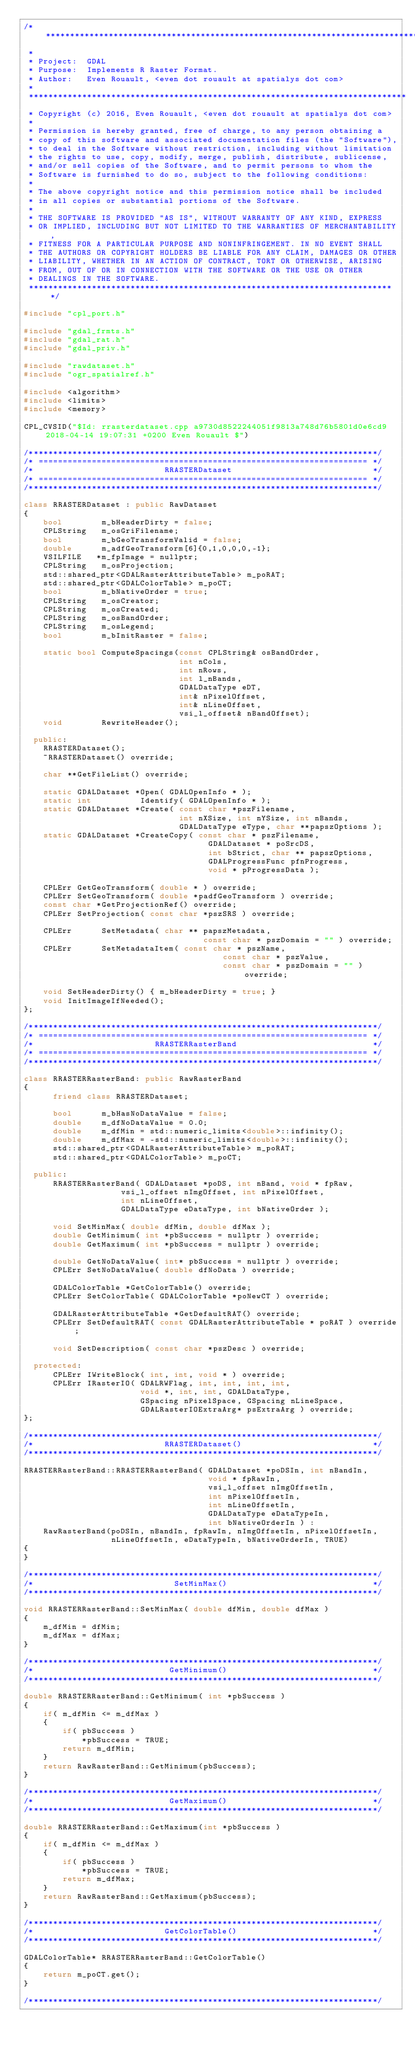Convert code to text. <code><loc_0><loc_0><loc_500><loc_500><_C++_>/******************************************************************************
 *
 * Project:  GDAL
 * Purpose:  Implements R Raster Format.
 * Author:   Even Rouault, <even dot rouault at spatialys dot com>
 *
 ******************************************************************************
 * Copyright (c) 2016, Even Rouault, <even dot rouault at spatialys dot com>
 *
 * Permission is hereby granted, free of charge, to any person obtaining a
 * copy of this software and associated documentation files (the "Software"),
 * to deal in the Software without restriction, including without limitation
 * the rights to use, copy, modify, merge, publish, distribute, sublicense,
 * and/or sell copies of the Software, and to permit persons to whom the
 * Software is furnished to do so, subject to the following conditions:
 *
 * The above copyright notice and this permission notice shall be included
 * in all copies or substantial portions of the Software.
 *
 * THE SOFTWARE IS PROVIDED "AS IS", WITHOUT WARRANTY OF ANY KIND, EXPRESS
 * OR IMPLIED, INCLUDING BUT NOT LIMITED TO THE WARRANTIES OF MERCHANTABILITY,
 * FITNESS FOR A PARTICULAR PURPOSE AND NONINFRINGEMENT. IN NO EVENT SHALL
 * THE AUTHORS OR COPYRIGHT HOLDERS BE LIABLE FOR ANY CLAIM, DAMAGES OR OTHER
 * LIABILITY, WHETHER IN AN ACTION OF CONTRACT, TORT OR OTHERWISE, ARISING
 * FROM, OUT OF OR IN CONNECTION WITH THE SOFTWARE OR THE USE OR OTHER
 * DEALINGS IN THE SOFTWARE.
 ****************************************************************************/

#include "cpl_port.h"

#include "gdal_frmts.h"
#include "gdal_rat.h"
#include "gdal_priv.h"

#include "rawdataset.h"
#include "ogr_spatialref.h"

#include <algorithm>
#include <limits>
#include <memory>

CPL_CVSID("$Id: rrasterdataset.cpp a9730d8522244051f9813a748d76b5801d0e6cd9 2018-04-14 19:07:31 +0200 Even Rouault $")

/************************************************************************/
/* ==================================================================== */
/*                           RRASTERDataset                             */
/* ==================================================================== */
/************************************************************************/

class RRASTERDataset : public RawDataset
{
    bool        m_bHeaderDirty = false;
    CPLString   m_osGriFilename;
    bool        m_bGeoTransformValid = false;
    double      m_adfGeoTransform[6]{0,1,0,0,0,-1};
    VSILFILE   *m_fpImage = nullptr;
    CPLString   m_osProjection;
    std::shared_ptr<GDALRasterAttributeTable> m_poRAT;
    std::shared_ptr<GDALColorTable> m_poCT;
    bool        m_bNativeOrder = true;
    CPLString   m_osCreator;
    CPLString   m_osCreated;
    CPLString   m_osBandOrder;
    CPLString   m_osLegend;
    bool        m_bInitRaster = false;

    static bool ComputeSpacings(const CPLString& osBandOrder,
                                int nCols,
                                int nRows,
                                int l_nBands,
                                GDALDataType eDT,
                                int& nPixelOffset,
                                int& nLineOffset,
                                vsi_l_offset& nBandOffset);
    void        RewriteHeader();

  public:
    RRASTERDataset();
    ~RRASTERDataset() override;

    char **GetFileList() override;

    static GDALDataset *Open( GDALOpenInfo * );
    static int          Identify( GDALOpenInfo * );
    static GDALDataset *Create( const char *pszFilename,
                                int nXSize, int nYSize, int nBands,
                                GDALDataType eType, char **papszOptions );
    static GDALDataset *CreateCopy( const char * pszFilename,
                                      GDALDataset * poSrcDS,
                                      int bStrict, char ** papszOptions,
                                      GDALProgressFunc pfnProgress,
                                      void * pProgressData );

    CPLErr GetGeoTransform( double * ) override;
    CPLErr SetGeoTransform( double *padfGeoTransform ) override;
    const char *GetProjectionRef() override;
    CPLErr SetProjection( const char *pszSRS ) override;

    CPLErr      SetMetadata( char ** papszMetadata,
                                     const char * pszDomain = "" ) override;
    CPLErr      SetMetadataItem( const char * pszName,
                                         const char * pszValue,
                                         const char * pszDomain = "" ) override;

    void SetHeaderDirty() { m_bHeaderDirty = true; }
    void InitImageIfNeeded();
};

/************************************************************************/
/* ==================================================================== */
/*                         RRASTERRasterBand                            */
/* ==================================================================== */
/************************************************************************/

class RRASTERRasterBand: public RawRasterBand
{
      friend class RRASTERDataset;

      bool      m_bHasNoDataValue = false;
      double    m_dfNoDataValue = 0.0;
      double    m_dfMin = std::numeric_limits<double>::infinity();
      double    m_dfMax = -std::numeric_limits<double>::infinity();
      std::shared_ptr<GDALRasterAttributeTable> m_poRAT;
      std::shared_ptr<GDALColorTable> m_poCT;

  public:
      RRASTERRasterBand( GDALDataset *poDS, int nBand, void * fpRaw,
                    vsi_l_offset nImgOffset, int nPixelOffset,
                    int nLineOffset,
                    GDALDataType eDataType, int bNativeOrder );

      void SetMinMax( double dfMin, double dfMax );
      double GetMinimum( int *pbSuccess = nullptr ) override;
      double GetMaximum( int *pbSuccess = nullptr ) override;

      double GetNoDataValue( int* pbSuccess = nullptr ) override;
      CPLErr SetNoDataValue( double dfNoData ) override;

      GDALColorTable *GetColorTable() override;
      CPLErr SetColorTable( GDALColorTable *poNewCT ) override;

      GDALRasterAttributeTable *GetDefaultRAT() override;
      CPLErr SetDefaultRAT( const GDALRasterAttributeTable * poRAT ) override;

      void SetDescription( const char *pszDesc ) override;

  protected:
      CPLErr IWriteBlock( int, int, void * ) override;
      CPLErr IRasterIO( GDALRWFlag, int, int, int, int,
                        void *, int, int, GDALDataType,
                        GSpacing nPixelSpace, GSpacing nLineSpace,
                        GDALRasterIOExtraArg* psExtraArg ) override;
};

/************************************************************************/
/*                           RRASTERDataset()                           */
/************************************************************************/

RRASTERRasterBand::RRASTERRasterBand( GDALDataset *poDSIn, int nBandIn,
                                      void * fpRawIn,
                                      vsi_l_offset nImgOffsetIn,
                                      int nPixelOffsetIn,
                                      int nLineOffsetIn,
                                      GDALDataType eDataTypeIn,
                                      int bNativeOrderIn ) :
    RawRasterBand(poDSIn, nBandIn, fpRawIn, nImgOffsetIn, nPixelOffsetIn,
                  nLineOffsetIn, eDataTypeIn, bNativeOrderIn, TRUE)
{
}

/************************************************************************/
/*                             SetMinMax()                              */
/************************************************************************/

void RRASTERRasterBand::SetMinMax( double dfMin, double dfMax )
{
    m_dfMin = dfMin;
    m_dfMax = dfMax;
}

/************************************************************************/
/*                            GetMinimum()                              */
/************************************************************************/

double RRASTERRasterBand::GetMinimum( int *pbSuccess )
{
    if( m_dfMin <= m_dfMax )
    {
        if( pbSuccess )
            *pbSuccess = TRUE;
        return m_dfMin;
    }
    return RawRasterBand::GetMinimum(pbSuccess);
}

/************************************************************************/
/*                            GetMaximum()                              */
/************************************************************************/

double RRASTERRasterBand::GetMaximum(int *pbSuccess )
{
    if( m_dfMin <= m_dfMax )
    {
        if( pbSuccess )
            *pbSuccess = TRUE;
        return m_dfMax;
    }
    return RawRasterBand::GetMaximum(pbSuccess);
}

/************************************************************************/
/*                           GetColorTable()                            */
/************************************************************************/

GDALColorTable* RRASTERRasterBand::GetColorTable()
{
    return m_poCT.get();
}

/************************************************************************/</code> 